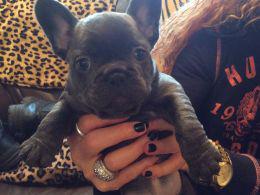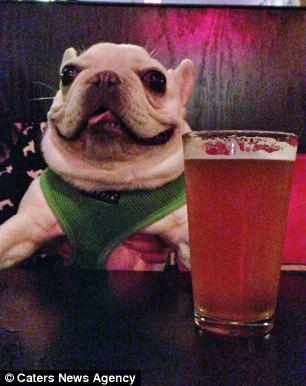The first image is the image on the left, the second image is the image on the right. Assess this claim about the two images: "At least two dogs are wearing costumes.". Correct or not? Answer yes or no. No. The first image is the image on the left, the second image is the image on the right. Given the left and right images, does the statement "A dog can be seen sitting on a carpet." hold true? Answer yes or no. No. 